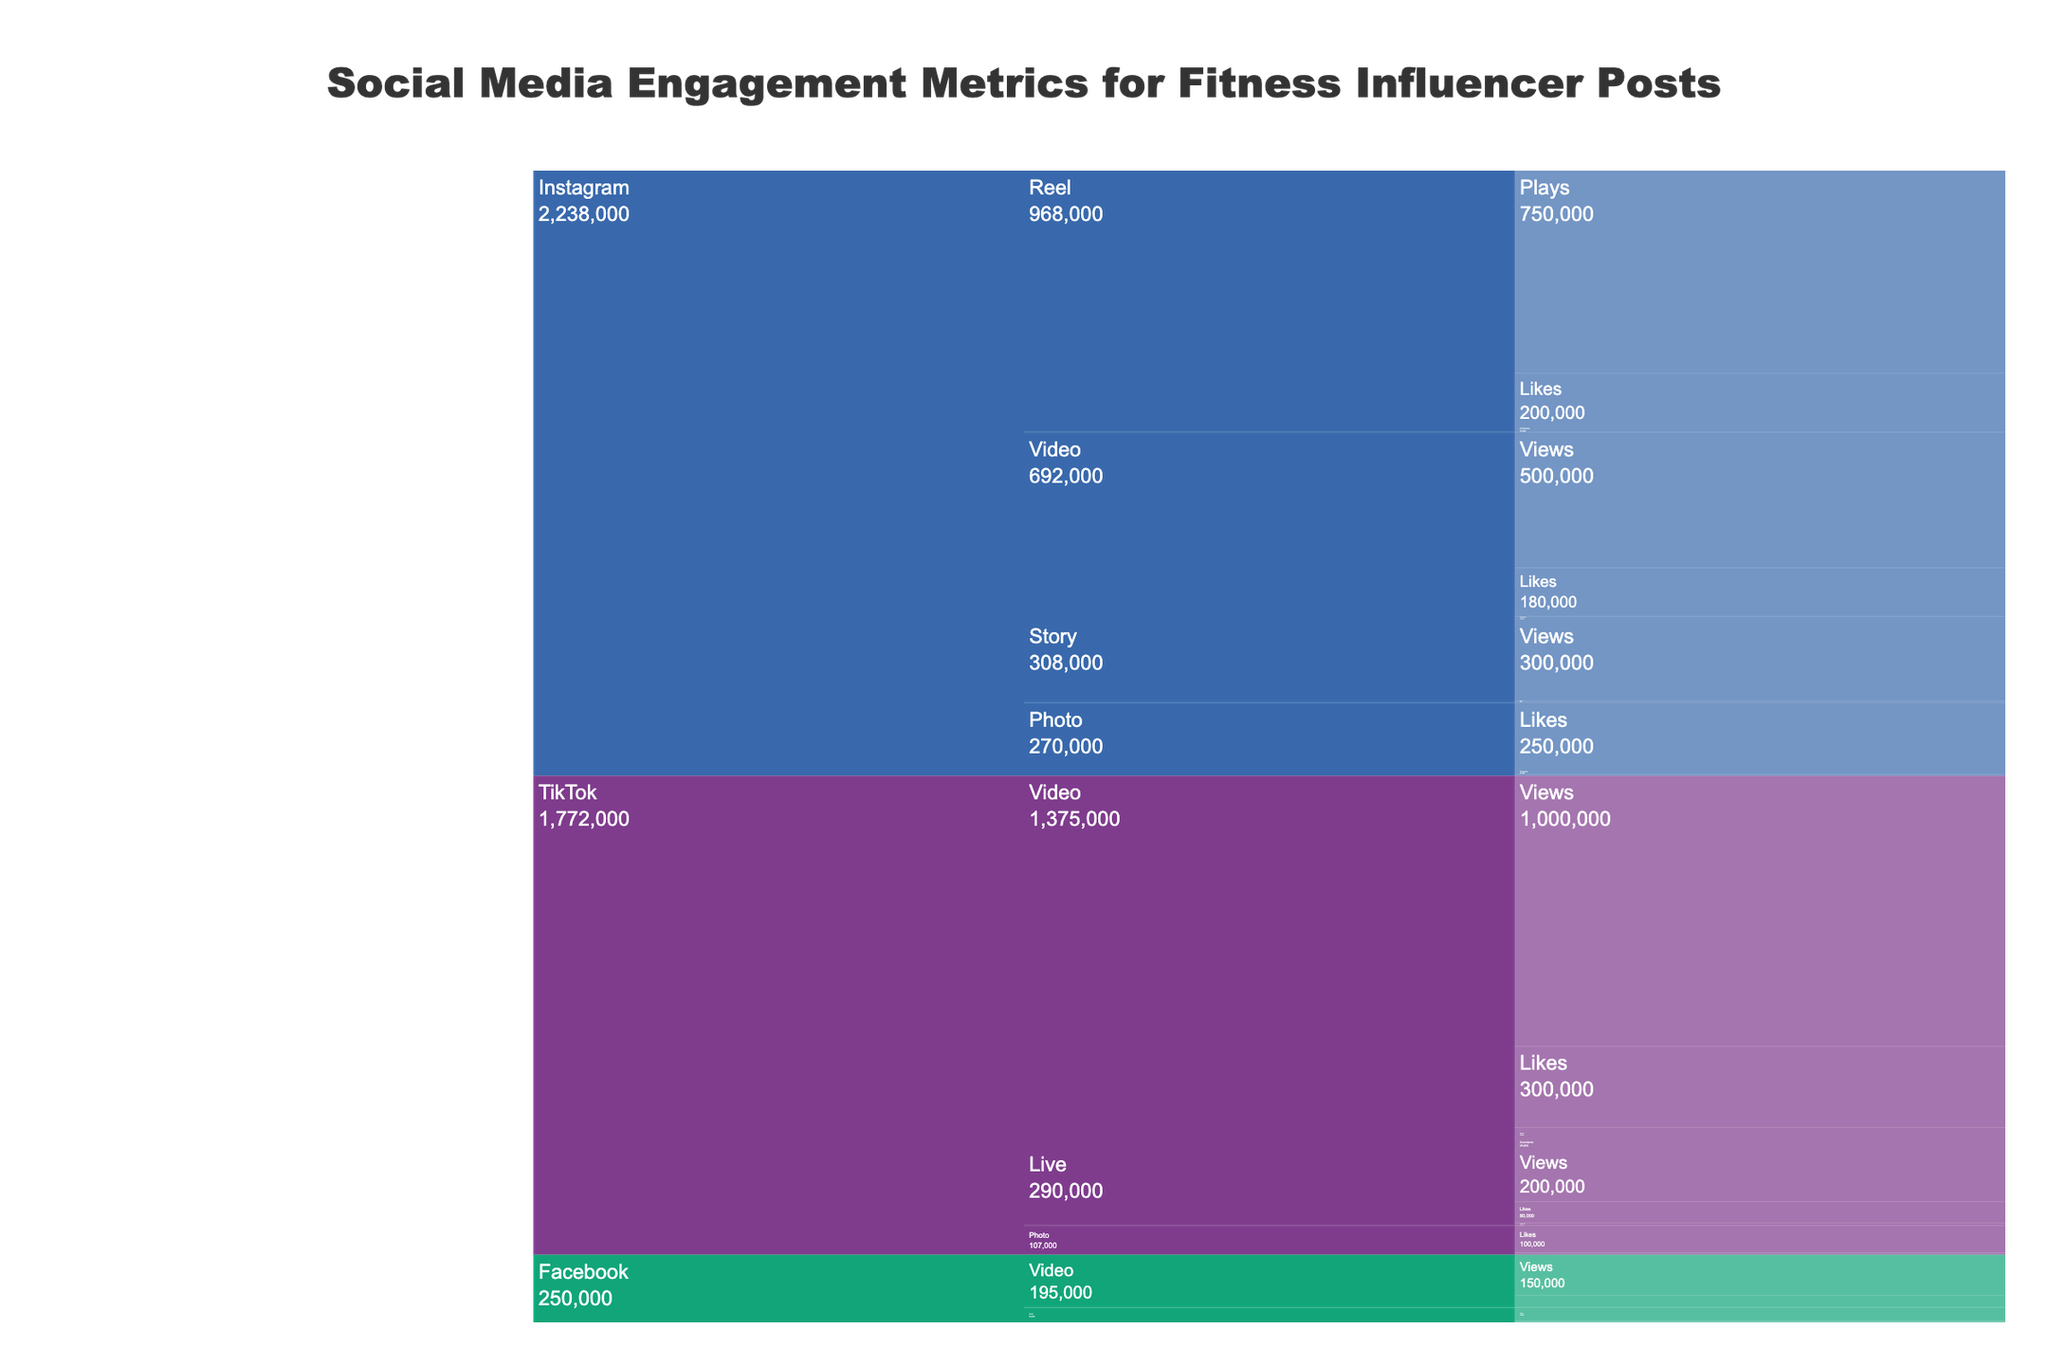what is the most common engagement type for Instagram photo posts? To determine the most common engagement type, look at the Instagram Photo branch and compare Likes, Comments, and Shares. The engagement type with the highest value is the most common.
Answer: Likes Which platform has the highest engagement for video content? Evaluate the total engagement values for video content across all platforms. Add the individual metrics for each platform's video content. Compare the sums to see which is highest.
Answer: TikTok What is the sum of all engagement metrics for story posts on Instagram? Look at the Story branch under Instagram and sum the values of Views and Replies. = 300,000 (Views) + 8,000 (Replies).
Answer: 308,000 How do Instagram and Facebook compare in terms of Likes for all content types combined? Add the Likes for all content under Instagram and Facebook. Instagram: 250,000 (Photo) + 180,000 (Video) + 200,000 (Reel) = 630,000. Facebook: 50,000 (Post) + 40,000 (Video) = 90,000. Then compare the totals.
Answer: Instagram has more Likes Which content type on TikTok generates the most Shares? Look at the Shares metric for each content type under TikTok. TikTok only shows Shares for Photos and Videos. Then identify the highest value.
Answer: Video Where do fitness influencers get the most comments? Compare the Comments metrics for all content types across all platforms. The highest number of Comments will determine where influencers get the most.
Answer: TikTok Video How do the number of plays for Reels on Instagram compare to the number of views for Videos on TikTok? Compare the values for the Plays of Instagram Reels and Views of TikTok Videos directly. Plays measure engagement for Reels, and Views for Videos. Reels (750,000) vs. Videos (1,000,000).
Answer: TikTok Videos have more What is the average number of views for video content across all platforms? Sum all views for video content across platforms and divide by the number of platforms. Instagram: 500,000, TikTok: 1,000,000, Facebook: 150,000. Average = (500,000 + 1,000,000 + 150,000) / 3.
Answer: 550,000 Which platform has the least total engagement for Photo posts? Sum the engagement metrics (Likes + Comments + Shares) for Photo posts across all platforms: Instagram, TikTok. Compare the totals to find the smallest value.
Answer: Facebook What is the median value of likes on video posts across all platforms? List out the number of Likes for video posts from each platform: Instagram (180,000), TikTok (300,000), Facebook (40,000). Order them and find the middle value.
Answer: 180,000 